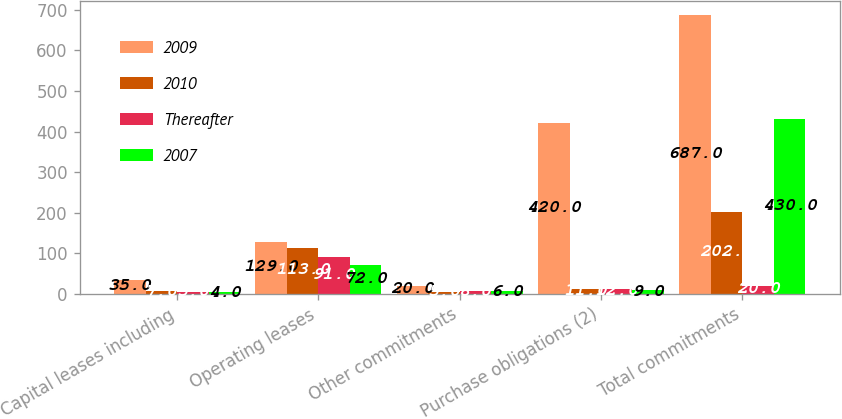<chart> <loc_0><loc_0><loc_500><loc_500><stacked_bar_chart><ecel><fcel>Capital leases including<fcel>Operating leases<fcel>Other commitments<fcel>Purchase obligations (2)<fcel>Total commitments<nl><fcel>2009<fcel>35<fcel>129<fcel>20<fcel>420<fcel>687<nl><fcel>2010<fcel>7<fcel>113<fcel>5<fcel>11<fcel>202<nl><fcel>Thereafter<fcel>5<fcel>91<fcel>8<fcel>12<fcel>20<nl><fcel>2007<fcel>4<fcel>72<fcel>6<fcel>9<fcel>430<nl></chart> 